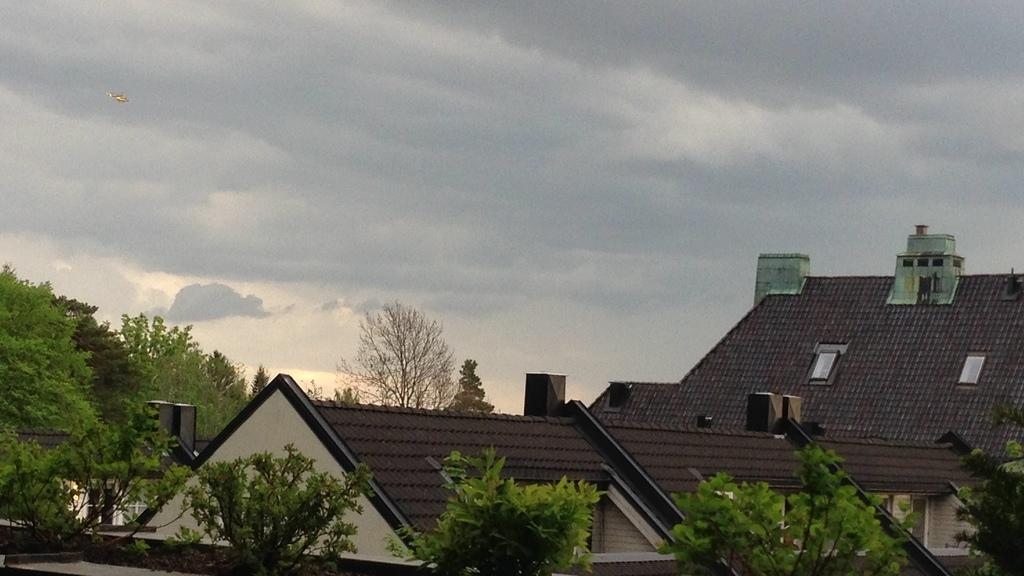What type of natural elements can be seen in the image? There are trees in the image. What type of man-made structures are present in the image? There are buildings in the image. What mode of transportation is visible in the air? There is an aircraft in the air. What is the condition of the sky in the image? The sky is cloudy. Reasoning: Let's think step by step by breaking down the image into its main components. We start by identifying the natural elements, which are the trees. Then, we move on to the man-made structures, which are the buildings. Next, we focus on the transportation aspect, which is the aircraft in the air. Finally, we describe the sky's condition, which is cloudy. This approach allows us to create a comprehensive conversation about the image while ensuring that each question can be answered definitively with the provided facts. Absurd Question/Answer: What type of list is being compiled by the trees in the image? There is no list being compiled by the trees in the image, as trees are natural elements and do not engage in such activities. 